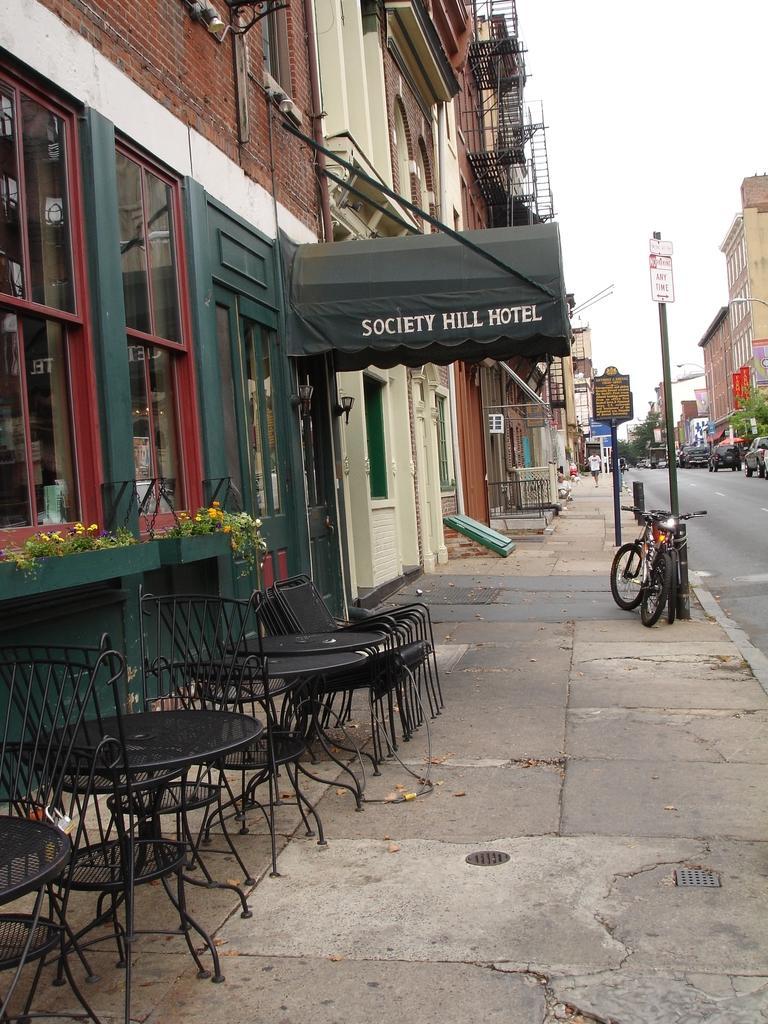Please provide a concise description of this image. In this image I see number of buildings and I see the chairs and tables over here and I see the path and I see the plants over here and I see something is written over here. In the background I see few vehicles over here and I see the boards on the poles and I see a bike over here and I see the sky. 